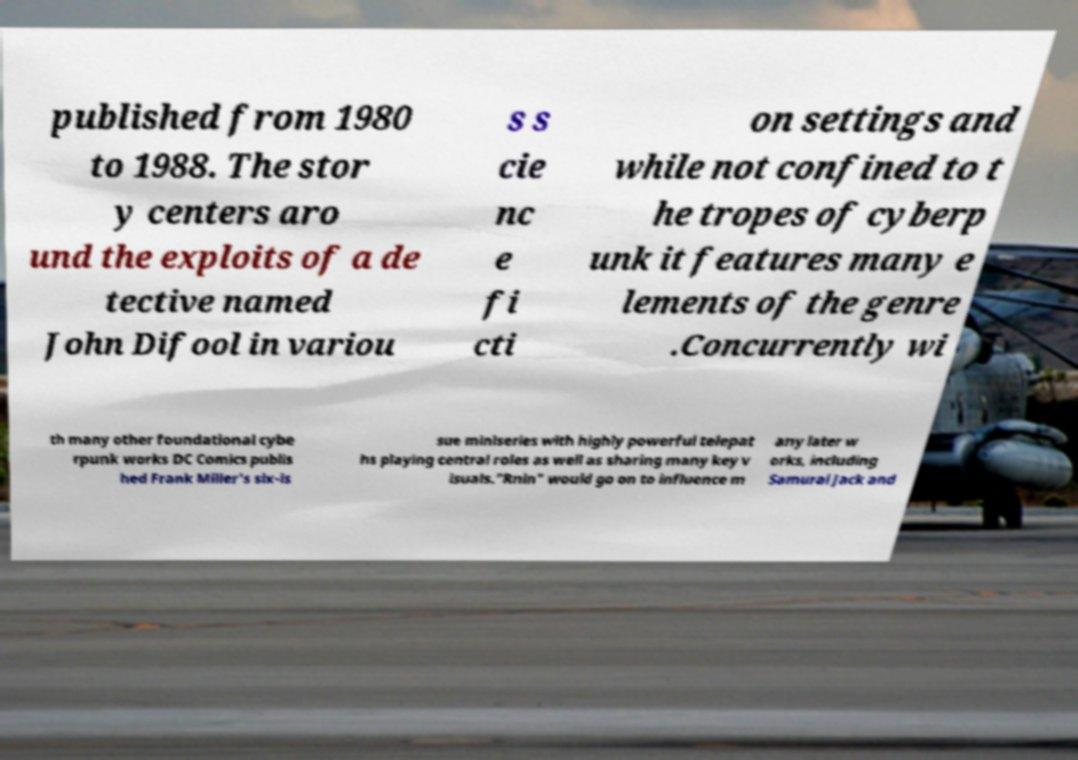There's text embedded in this image that I need extracted. Can you transcribe it verbatim? published from 1980 to 1988. The stor y centers aro und the exploits of a de tective named John Difool in variou s s cie nc e fi cti on settings and while not confined to t he tropes of cyberp unk it features many e lements of the genre .Concurrently wi th many other foundational cybe rpunk works DC Comics publis hed Frank Miller's six-is sue miniseries with highly powerful telepat hs playing central roles as well as sharing many key v isuals."Rnin" would go on to influence m any later w orks, including Samurai Jack and 